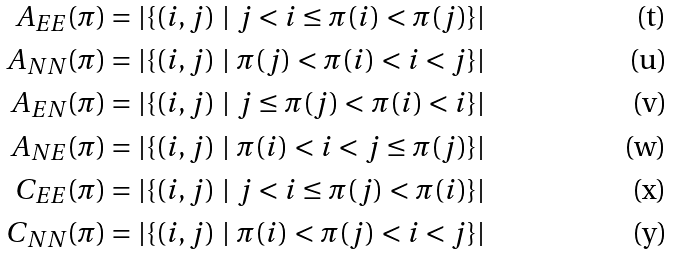<formula> <loc_0><loc_0><loc_500><loc_500>A _ { E E } ( \pi ) & = | \{ ( i , j ) \ | \ j < i \leq \pi ( i ) < \pi ( j ) \} | \\ A _ { N N } ( \pi ) & = | \{ ( i , j ) \ | \ \pi ( j ) < \pi ( i ) < i < j \} | \\ A _ { E N } ( \pi ) & = | \{ ( i , j ) \ | \ j \leq \pi ( j ) < \pi ( i ) < i \} | \\ A _ { N E } ( \pi ) & = | \{ ( i , j ) \ | \ \pi ( i ) < i < j \leq \pi ( j ) \} | \\ C _ { E E } ( \pi ) & = | \{ ( i , j ) \ | \ j < i \leq \pi ( j ) < \pi ( i ) \} | \\ C _ { N N } ( \pi ) & = | \{ ( i , j ) \ | \ \pi ( i ) < \pi ( j ) < i < j \} |</formula> 